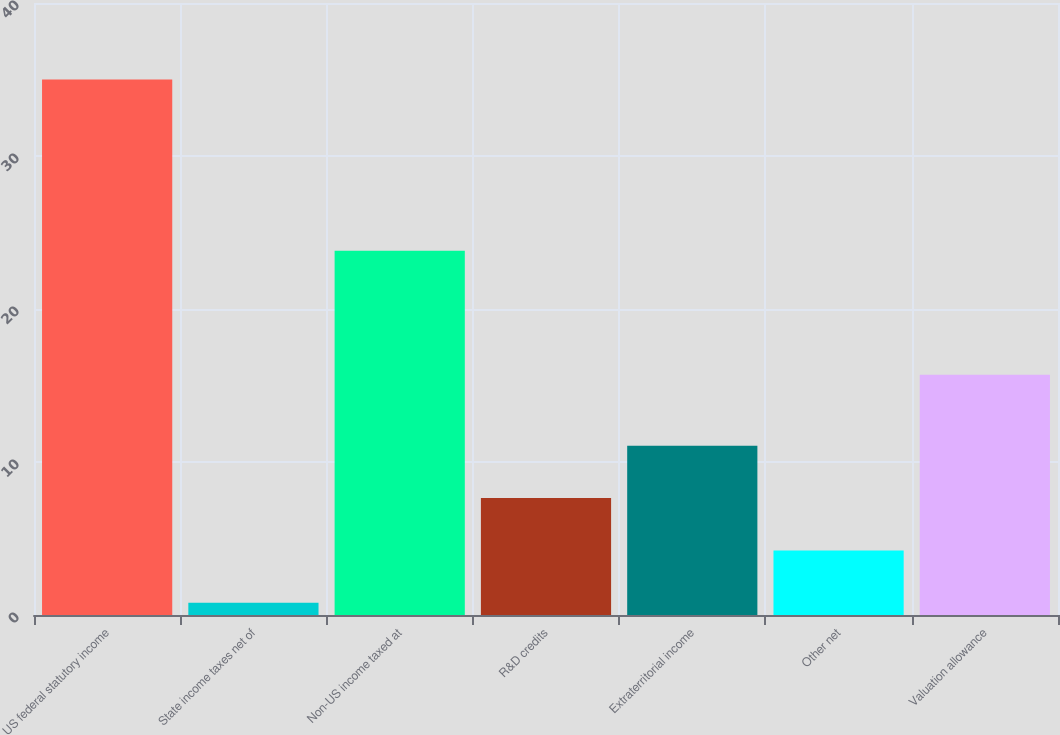<chart> <loc_0><loc_0><loc_500><loc_500><bar_chart><fcel>US federal statutory income<fcel>State income taxes net of<fcel>Non-US income taxed at<fcel>R&D credits<fcel>Extraterritorial income<fcel>Other net<fcel>Valuation allowance<nl><fcel>35<fcel>0.8<fcel>23.8<fcel>7.64<fcel>11.06<fcel>4.22<fcel>15.7<nl></chart> 